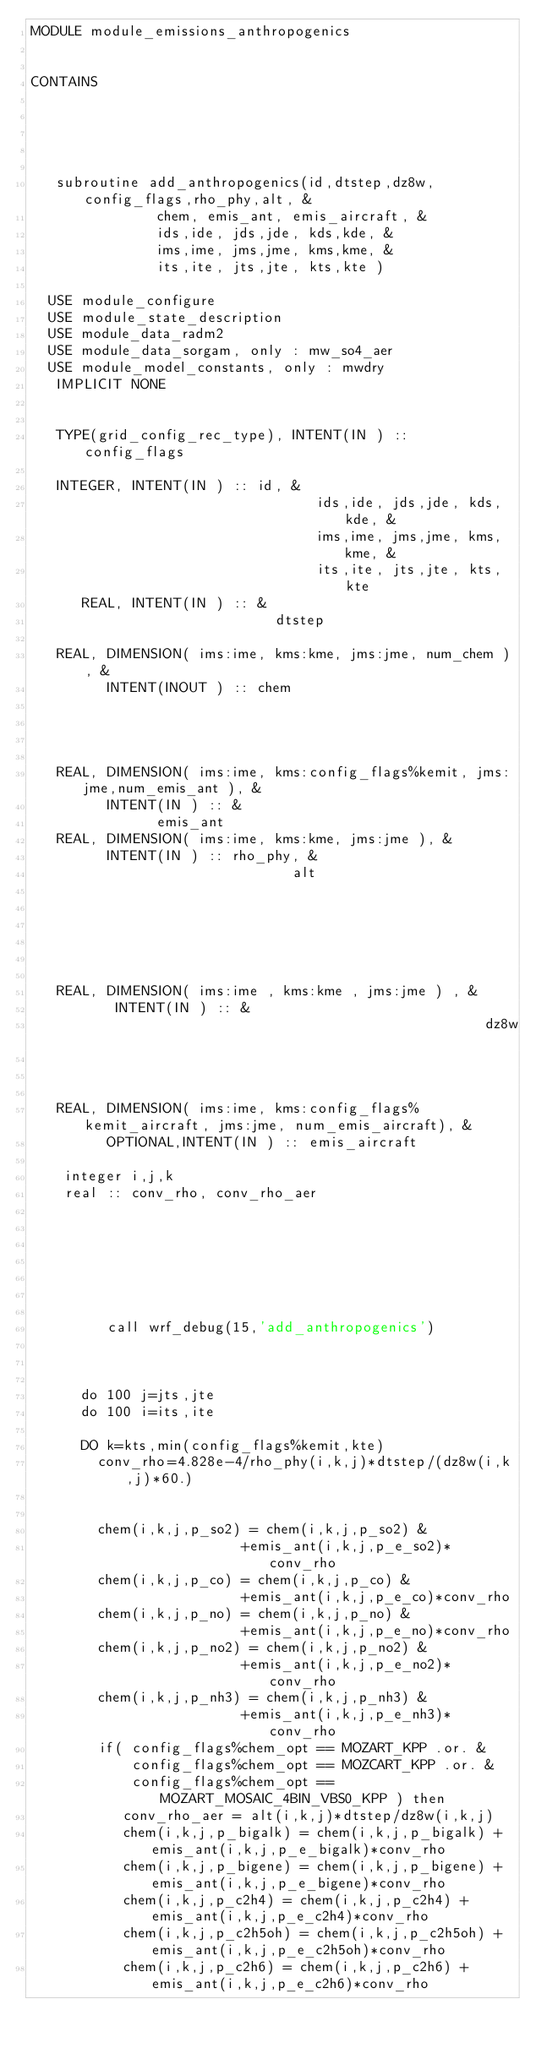Convert code to text. <code><loc_0><loc_0><loc_500><loc_500><_FORTRAN_>MODULE module_emissions_anthropogenics


CONTAINS





   subroutine add_anthropogenics(id,dtstep,dz8w,config_flags,rho_phy,alt, &
               chem, emis_ant, emis_aircraft, &
               ids,ide, jds,jde, kds,kde, &
               ims,ime, jms,jme, kms,kme, &
               its,ite, jts,jte, kts,kte )

  USE module_configure
  USE module_state_description
  USE module_data_radm2
  USE module_data_sorgam, only : mw_so4_aer
  USE module_model_constants, only : mwdry
   IMPLICIT NONE


   TYPE(grid_config_rec_type), INTENT(IN ) :: config_flags

   INTEGER, INTENT(IN ) :: id, &
                                  ids,ide, jds,jde, kds,kde, &
                                  ims,ime, jms,jme, kms,kme, &
                                  its,ite, jts,jte, kts,kte
      REAL, INTENT(IN ) :: &
                             dtstep

   REAL, DIMENSION( ims:ime, kms:kme, jms:jme, num_chem ), &
         INTENT(INOUT ) :: chem




   REAL, DIMENSION( ims:ime, kms:config_flags%kemit, jms:jme,num_emis_ant ), &
         INTENT(IN ) :: &
               emis_ant
   REAL, DIMENSION( ims:ime, kms:kme, jms:jme ), &
         INTENT(IN ) :: rho_phy, &
                               alt






   REAL, DIMENSION( ims:ime , kms:kme , jms:jme ) , &
          INTENT(IN ) :: &
                                                      dz8w



   REAL, DIMENSION( ims:ime, kms:config_flags%kemit_aircraft, jms:jme, num_emis_aircraft), &
         OPTIONAL,INTENT(IN ) :: emis_aircraft

    integer i,j,k
    real :: conv_rho, conv_rho_aer







         call wrf_debug(15,'add_anthropogenics')



      do 100 j=jts,jte
      do 100 i=its,ite

      DO k=kts,min(config_flags%kemit,kte)
        conv_rho=4.828e-4/rho_phy(i,k,j)*dtstep/(dz8w(i,k,j)*60.)


        chem(i,k,j,p_so2) = chem(i,k,j,p_so2) &
                         +emis_ant(i,k,j,p_e_so2)*conv_rho
        chem(i,k,j,p_co) = chem(i,k,j,p_co) &
                         +emis_ant(i,k,j,p_e_co)*conv_rho
        chem(i,k,j,p_no) = chem(i,k,j,p_no) &
                         +emis_ant(i,k,j,p_e_no)*conv_rho
        chem(i,k,j,p_no2) = chem(i,k,j,p_no2) &
                         +emis_ant(i,k,j,p_e_no2)*conv_rho
        chem(i,k,j,p_nh3) = chem(i,k,j,p_nh3) &
                         +emis_ant(i,k,j,p_e_nh3)*conv_rho
        if( config_flags%chem_opt == MOZART_KPP .or. &
            config_flags%chem_opt == MOZCART_KPP .or. &
            config_flags%chem_opt == MOZART_MOSAIC_4BIN_VBS0_KPP ) then
           conv_rho_aer = alt(i,k,j)*dtstep/dz8w(i,k,j)
           chem(i,k,j,p_bigalk) = chem(i,k,j,p_bigalk) + emis_ant(i,k,j,p_e_bigalk)*conv_rho
           chem(i,k,j,p_bigene) = chem(i,k,j,p_bigene) + emis_ant(i,k,j,p_e_bigene)*conv_rho
           chem(i,k,j,p_c2h4) = chem(i,k,j,p_c2h4) + emis_ant(i,k,j,p_e_c2h4)*conv_rho
           chem(i,k,j,p_c2h5oh) = chem(i,k,j,p_c2h5oh) + emis_ant(i,k,j,p_e_c2h5oh)*conv_rho
           chem(i,k,j,p_c2h6) = chem(i,k,j,p_c2h6) + emis_ant(i,k,j,p_e_c2h6)*conv_rho</code> 